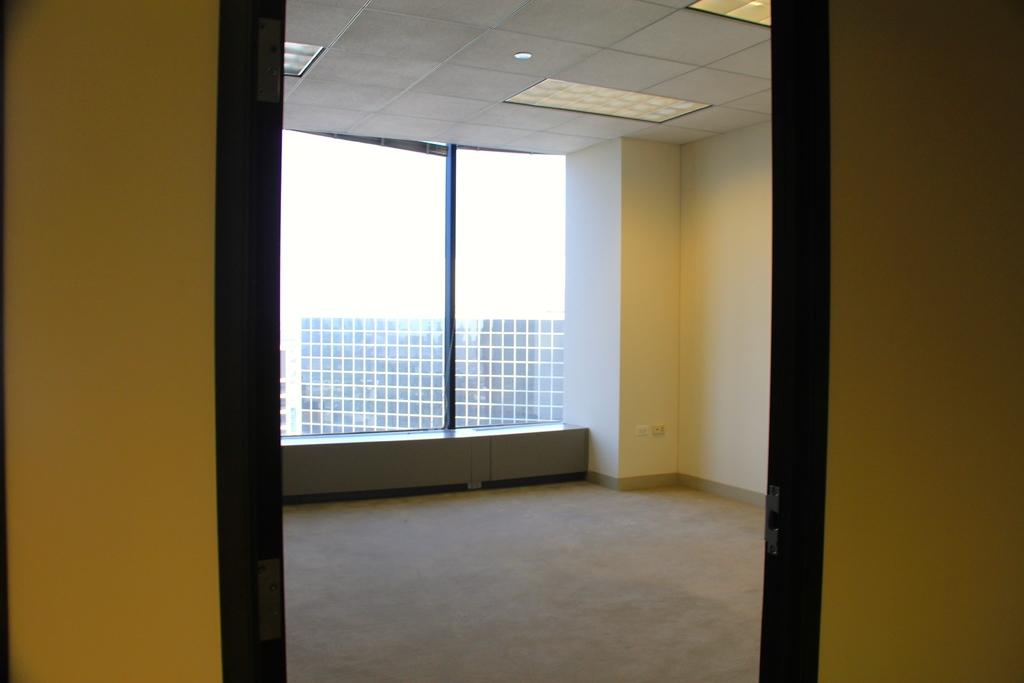What type of space is shown in the image? The image depicts a room. What color are the walls in the room? The walls in the room are yellow. What feature allows natural light to enter the room? There is a glass window in the room. What can be seen in the background of the image? There is a building visible in the background of the image. Where is the table located in the image? There is no table present in the image. What type of bag can be seen hanging on the wall in the image? There is no bag visible in the image. 